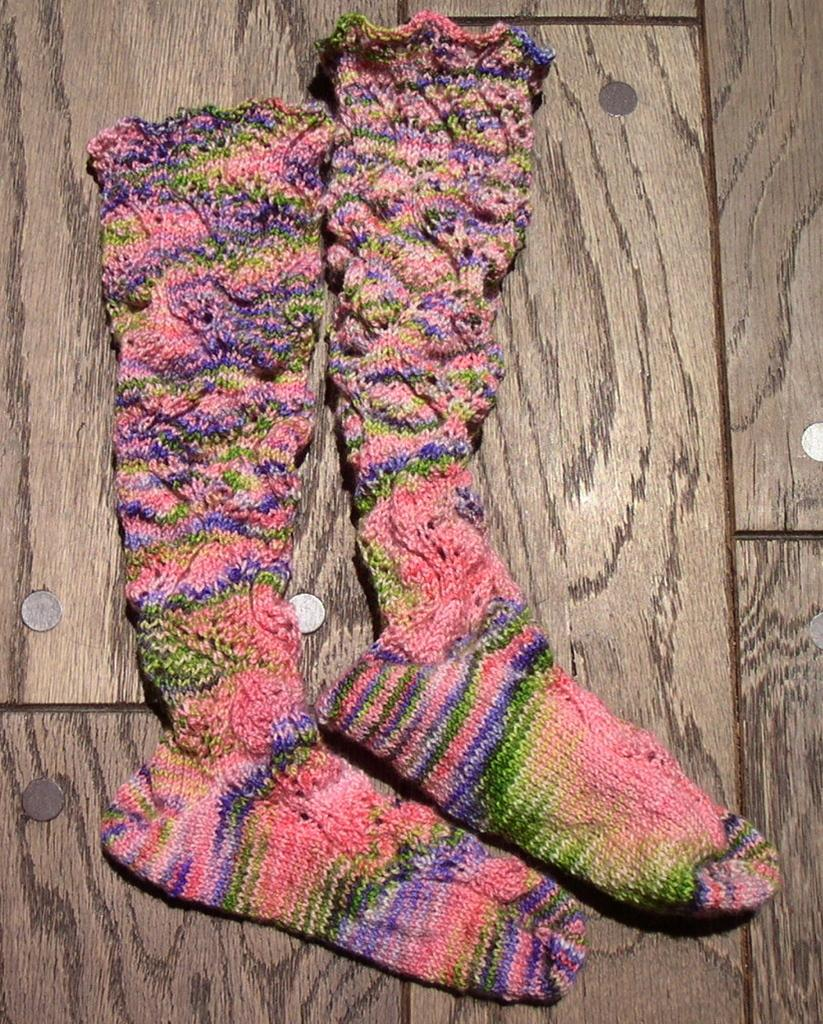What items can be seen on the floor in the image? There are socks and coins on the floor in the image. What type of material is the floor made of? The floor appears to be made of tiles. How many trees can be seen in the image? There are no trees present in the image. What type of tool is being used to build a bridge in the image? There is no tool or bridge present in the image. 